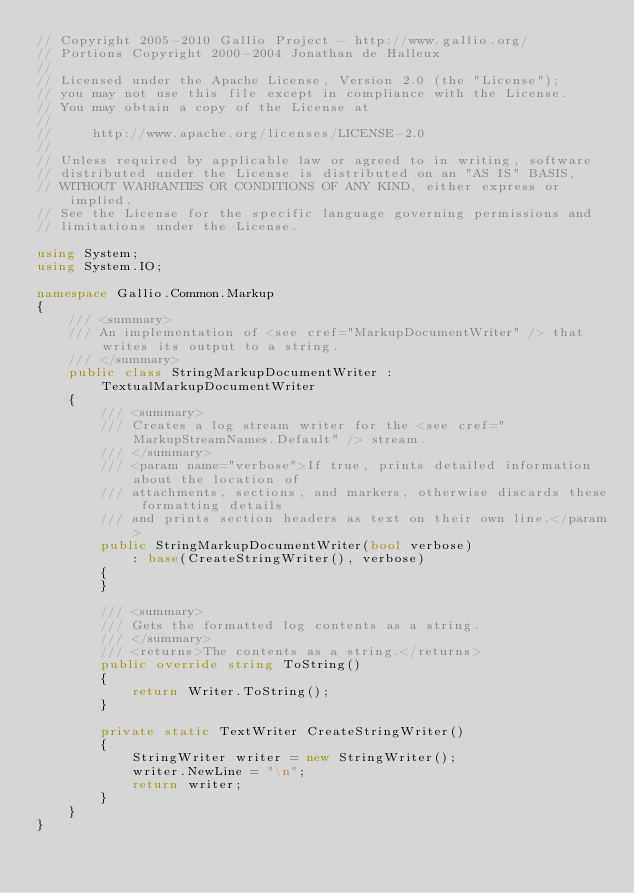Convert code to text. <code><loc_0><loc_0><loc_500><loc_500><_C#_>// Copyright 2005-2010 Gallio Project - http://www.gallio.org/
// Portions Copyright 2000-2004 Jonathan de Halleux
// 
// Licensed under the Apache License, Version 2.0 (the "License");
// you may not use this file except in compliance with the License.
// You may obtain a copy of the License at
// 
//     http://www.apache.org/licenses/LICENSE-2.0
// 
// Unless required by applicable law or agreed to in writing, software
// distributed under the License is distributed on an "AS IS" BASIS,
// WITHOUT WARRANTIES OR CONDITIONS OF ANY KIND, either express or implied.
// See the License for the specific language governing permissions and
// limitations under the License.

using System;
using System.IO;

namespace Gallio.Common.Markup
{
    /// <summary>
    /// An implementation of <see cref="MarkupDocumentWriter" /> that writes its output to a string.
    /// </summary>
    public class StringMarkupDocumentWriter : TextualMarkupDocumentWriter
    {
        /// <summary>
        /// Creates a log stream writer for the <see cref="MarkupStreamNames.Default" /> stream.
        /// </summary>
        /// <param name="verbose">If true, prints detailed information about the location of
        /// attachments, sections, and markers, otherwise discards these formatting details
        /// and prints section headers as text on their own line.</param>
        public StringMarkupDocumentWriter(bool verbose)
            : base(CreateStringWriter(), verbose)
        {
        }

        /// <summary>
        /// Gets the formatted log contents as a string.
        /// </summary>
        /// <returns>The contents as a string.</returns>
        public override string ToString()
        {
            return Writer.ToString();
        }

        private static TextWriter CreateStringWriter()
        {
            StringWriter writer = new StringWriter();
            writer.NewLine = "\n";
            return writer;
        }
    }
}
</code> 